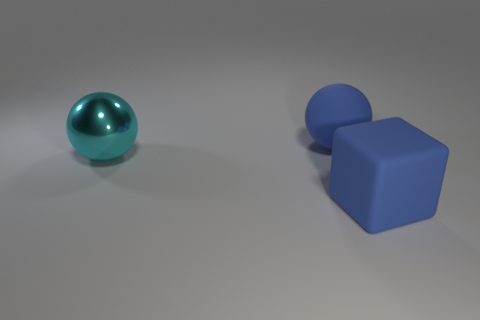Is there any other thing that has the same material as the cyan thing?
Keep it short and to the point. No. What number of blocks are large blue objects or cyan metallic things?
Ensure brevity in your answer.  1. Is there a large rubber ball?
Provide a short and direct response. Yes. What is the shape of the large cyan object that is to the left of the big blue thing that is to the left of the matte cube?
Your response must be concise. Sphere. How many cyan things are either large matte things or spheres?
Give a very brief answer. 1. What color is the matte ball?
Ensure brevity in your answer.  Blue. Do the blue sphere and the large blue object in front of the large cyan metal ball have the same material?
Provide a succinct answer. Yes. There is a matte ball right of the cyan object; is it the same color as the block?
Your answer should be compact. Yes. How many blue objects are both in front of the big metallic sphere and behind the block?
Offer a terse response. 0. How many other things are the same material as the big blue cube?
Your response must be concise. 1. 